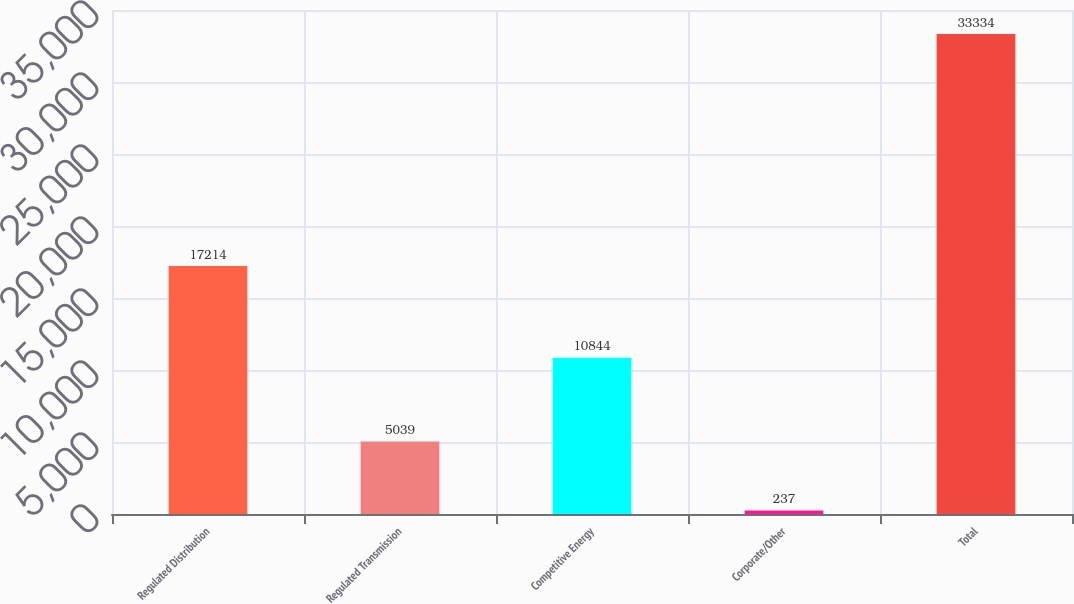Convert chart. <chart><loc_0><loc_0><loc_500><loc_500><bar_chart><fcel>Regulated Distribution<fcel>Regulated Transmission<fcel>Competitive Energy<fcel>Corporate/Other<fcel>Total<nl><fcel>17214<fcel>5039<fcel>10844<fcel>237<fcel>33334<nl></chart> 